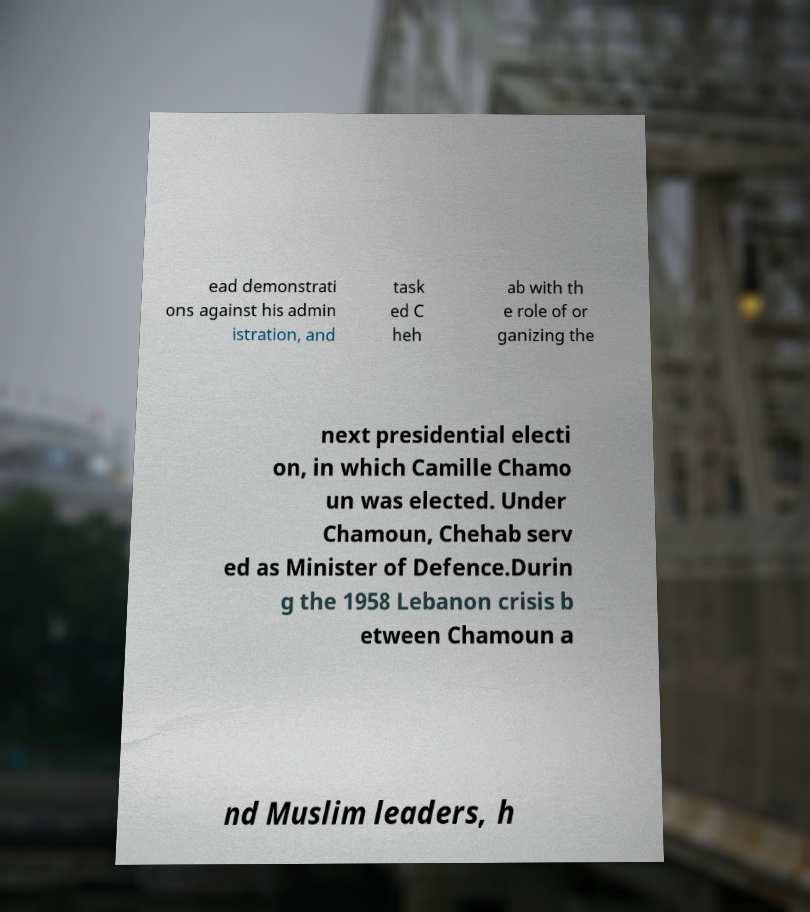Could you extract and type out the text from this image? ead demonstrati ons against his admin istration, and task ed C heh ab with th e role of or ganizing the next presidential electi on, in which Camille Chamo un was elected. Under Chamoun, Chehab serv ed as Minister of Defence.Durin g the 1958 Lebanon crisis b etween Chamoun a nd Muslim leaders, h 